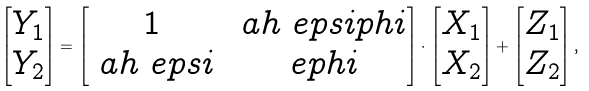<formula> <loc_0><loc_0><loc_500><loc_500>\begin{bmatrix} Y _ { 1 } \\ Y _ { 2 } \end{bmatrix} = \begin{bmatrix} 1 & \ a h \ e p s i p h i \\ \ a h \ e p s i & \ e p h i \end{bmatrix} \cdot \begin{bmatrix} X _ { 1 } \\ X _ { 2 } \end{bmatrix} + \begin{bmatrix} Z _ { 1 } \\ Z _ { 2 } \end{bmatrix} ,</formula> 